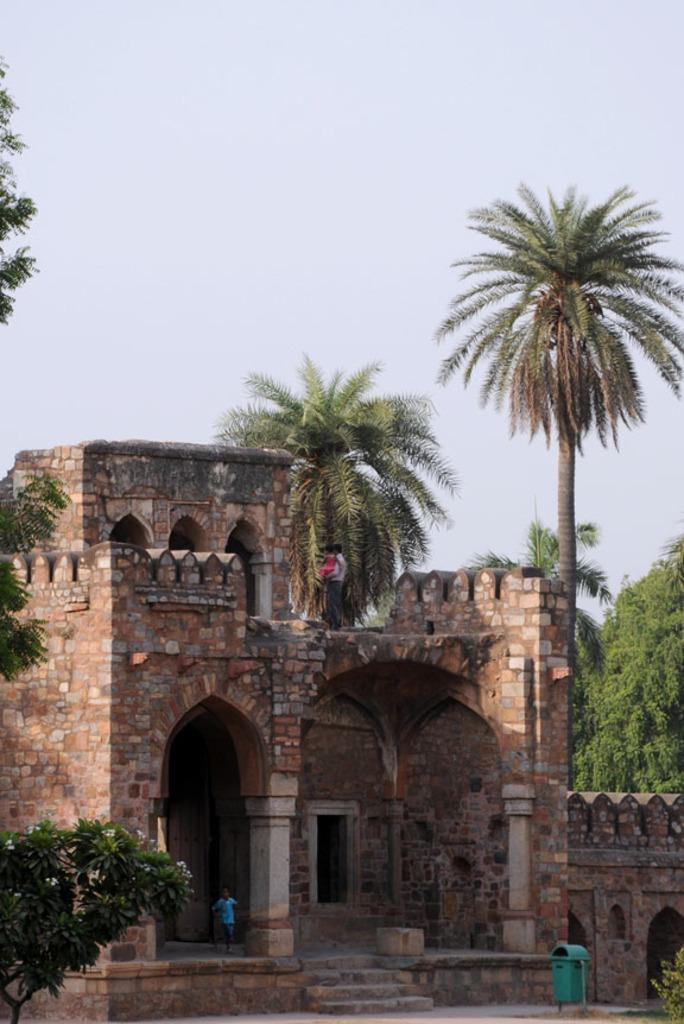What type of structure is visible in the image? There is a building in the image. Who or what else can be seen in the image? There are people and a dustbin visible in the image. What can be seen in the background of the image? There are trees in the background of the image. What is the condition of the sky in the image? The sky is clear in the image. How many sheep are visible in the image? There are no sheep present in the image. What type of wealth is depicted in the image? There is no depiction of wealth in the image. 